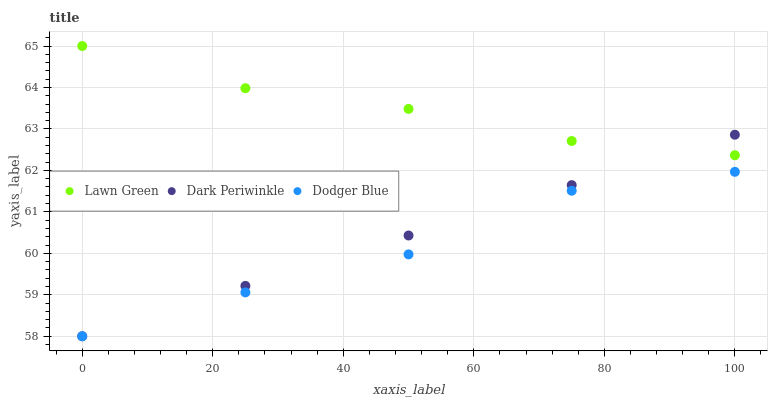Does Dodger Blue have the minimum area under the curve?
Answer yes or no. Yes. Does Lawn Green have the maximum area under the curve?
Answer yes or no. Yes. Does Dark Periwinkle have the minimum area under the curve?
Answer yes or no. No. Does Dark Periwinkle have the maximum area under the curve?
Answer yes or no. No. Is Dark Periwinkle the smoothest?
Answer yes or no. Yes. Is Dodger Blue the roughest?
Answer yes or no. Yes. Is Dodger Blue the smoothest?
Answer yes or no. No. Is Dark Periwinkle the roughest?
Answer yes or no. No. Does Dodger Blue have the lowest value?
Answer yes or no. Yes. Does Lawn Green have the highest value?
Answer yes or no. Yes. Does Dark Periwinkle have the highest value?
Answer yes or no. No. Is Dodger Blue less than Lawn Green?
Answer yes or no. Yes. Is Lawn Green greater than Dodger Blue?
Answer yes or no. Yes. Does Dark Periwinkle intersect Dodger Blue?
Answer yes or no. Yes. Is Dark Periwinkle less than Dodger Blue?
Answer yes or no. No. Is Dark Periwinkle greater than Dodger Blue?
Answer yes or no. No. Does Dodger Blue intersect Lawn Green?
Answer yes or no. No. 